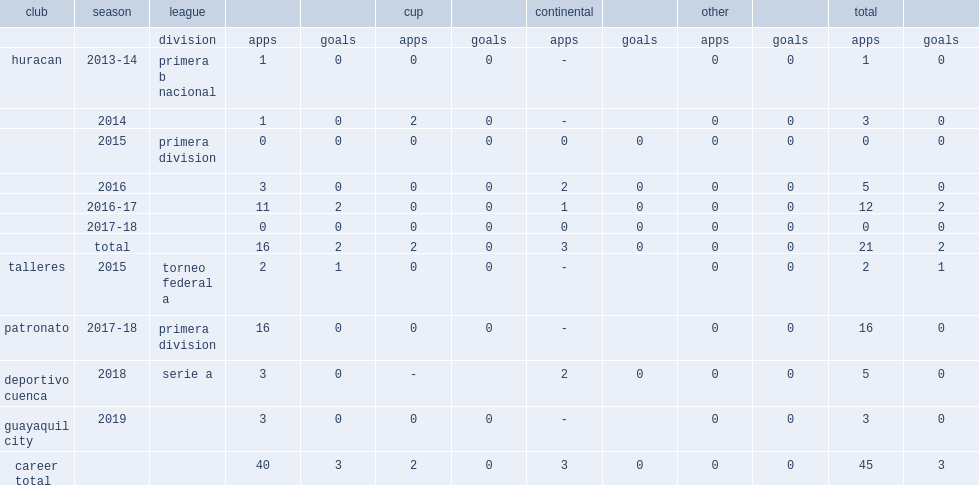Which league did sosa depart deportivo cuenca of and joined guayaquil city for the 2019 season? Serie a. 